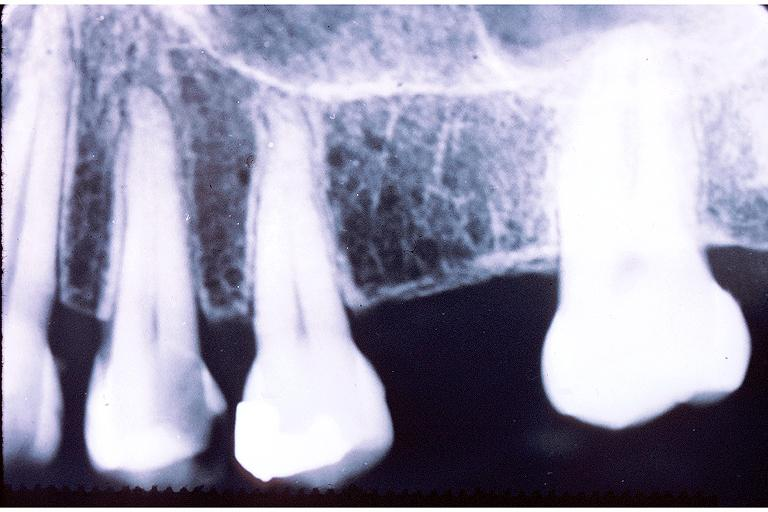s musculoskeletal present?
Answer the question using a single word or phrase. No 